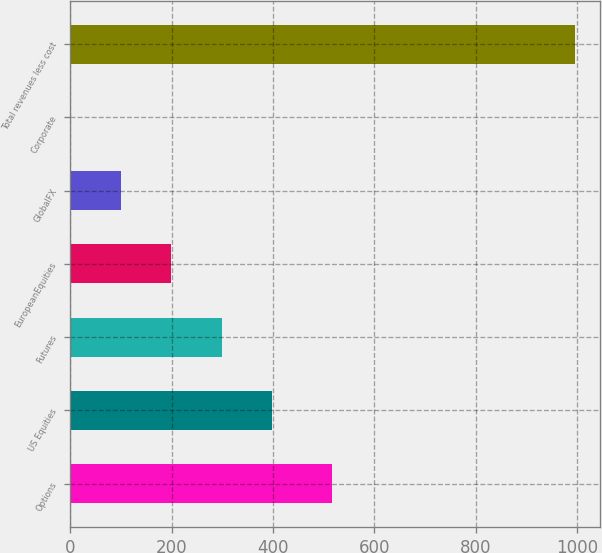Convert chart to OTSL. <chart><loc_0><loc_0><loc_500><loc_500><bar_chart><fcel>Options<fcel>US Equities<fcel>Futures<fcel>EuropeanEquities<fcel>GlobalFX<fcel>Corporate<fcel>Total revenues less cost<nl><fcel>516.3<fcel>398.66<fcel>299.17<fcel>199.68<fcel>100.19<fcel>0.7<fcel>995.6<nl></chart> 